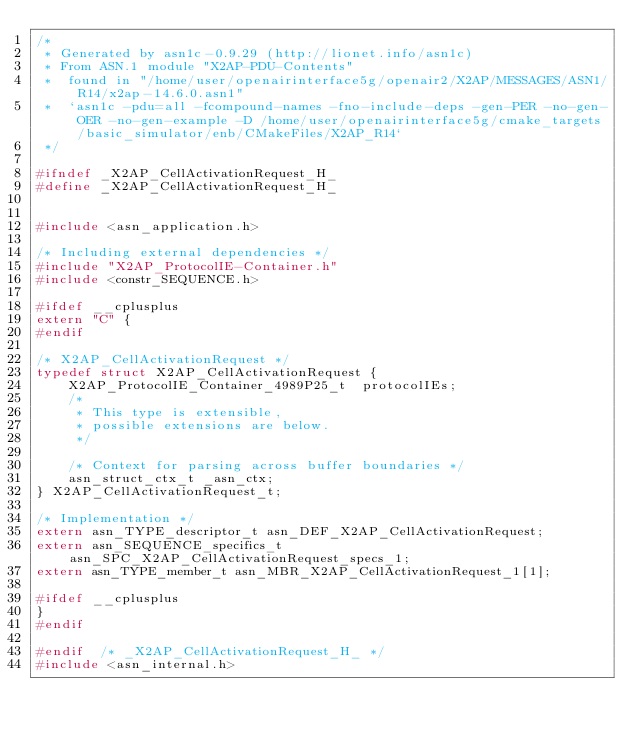<code> <loc_0><loc_0><loc_500><loc_500><_C_>/*
 * Generated by asn1c-0.9.29 (http://lionet.info/asn1c)
 * From ASN.1 module "X2AP-PDU-Contents"
 * 	found in "/home/user/openairinterface5g/openair2/X2AP/MESSAGES/ASN1/R14/x2ap-14.6.0.asn1"
 * 	`asn1c -pdu=all -fcompound-names -fno-include-deps -gen-PER -no-gen-OER -no-gen-example -D /home/user/openairinterface5g/cmake_targets/basic_simulator/enb/CMakeFiles/X2AP_R14`
 */

#ifndef	_X2AP_CellActivationRequest_H_
#define	_X2AP_CellActivationRequest_H_


#include <asn_application.h>

/* Including external dependencies */
#include "X2AP_ProtocolIE-Container.h"
#include <constr_SEQUENCE.h>

#ifdef __cplusplus
extern "C" {
#endif

/* X2AP_CellActivationRequest */
typedef struct X2AP_CellActivationRequest {
	X2AP_ProtocolIE_Container_4989P25_t	 protocolIEs;
	/*
	 * This type is extensible,
	 * possible extensions are below.
	 */
	
	/* Context for parsing across buffer boundaries */
	asn_struct_ctx_t _asn_ctx;
} X2AP_CellActivationRequest_t;

/* Implementation */
extern asn_TYPE_descriptor_t asn_DEF_X2AP_CellActivationRequest;
extern asn_SEQUENCE_specifics_t asn_SPC_X2AP_CellActivationRequest_specs_1;
extern asn_TYPE_member_t asn_MBR_X2AP_CellActivationRequest_1[1];

#ifdef __cplusplus
}
#endif

#endif	/* _X2AP_CellActivationRequest_H_ */
#include <asn_internal.h>
</code> 